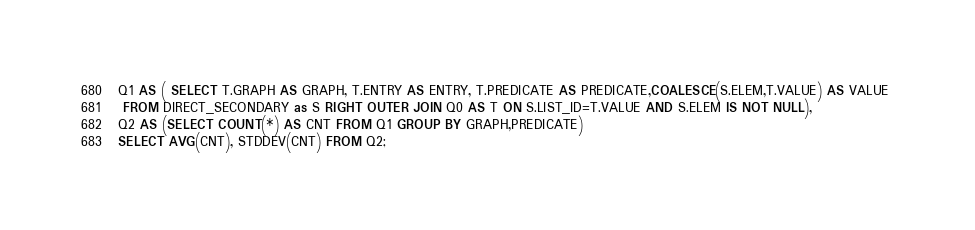Convert code to text. <code><loc_0><loc_0><loc_500><loc_500><_SQL_>Q1 AS ( SELECT T.GRAPH AS GRAPH, T.ENTRY AS ENTRY, T.PREDICATE AS PREDICATE,COALESCE(S.ELEM,T.VALUE) AS VALUE 
 FROM DIRECT_SECONDARY as S RIGHT OUTER JOIN Q0 AS T ON S.LIST_ID=T.VALUE AND S.ELEM IS NOT NULL),
Q2 AS (SELECT COUNT(*) AS CNT FROM Q1 GROUP BY GRAPH,PREDICATE)
SELECT AVG(CNT), STDDEV(CNT) FROM Q2;</code> 